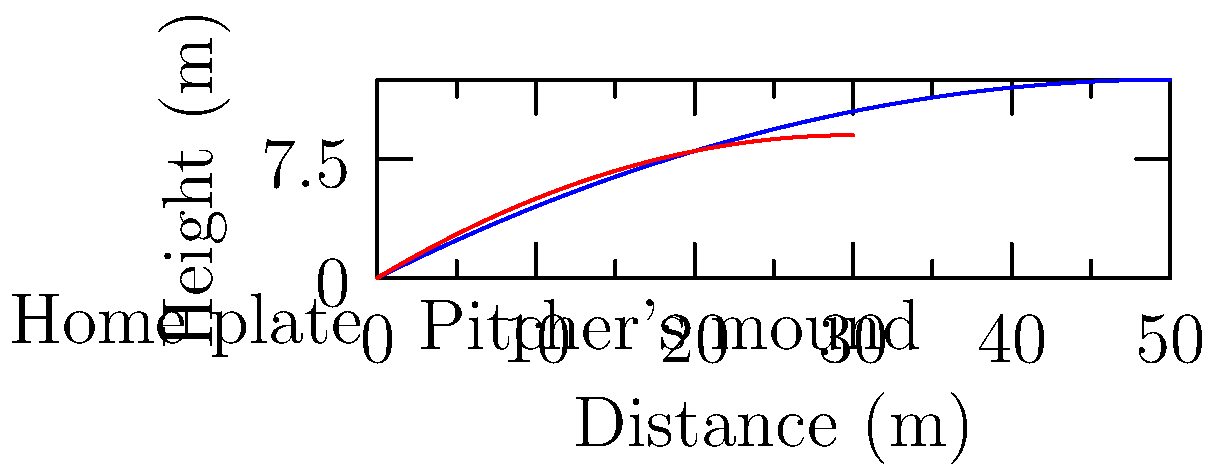Father Murphy was known for his unique pitching style during the annual church softball game. The blue curve represents a regular pitch, while the red curve shows Father Murphy's signature pitch. What factor likely contributed most to the difference in trajectories, and how might this have affected the batter's ability to hit the ball? To analyze the difference in trajectories:

1. Observe the curves:
   - Blue (regular pitch): longer, flatter trajectory
   - Red (Father Murphy's pitch): shorter, steeper trajectory

2. Consider factors affecting a pitch:
   - Initial velocity
   - Launch angle
   - Spin rate
   - Air resistance

3. Analyze the red curve:
   - Steeper initial ascent
   - Reaches maximum height quicker
   - Shorter overall distance

4. Conclude:
   - Father Murphy's pitch likely had a higher launch angle

5. Effects on the batter:
   - Less time to react due to steeper descent
   - Unexpected trajectory compared to standard pitches
   - Potential "rising" effect as the ball approaches

6. Biomechanical implication:
   - Father Murphy may have adjusted his arm angle or wrist position at release to achieve this trajectory

The higher launch angle would have made Father Murphy's pitches more challenging to hit, as batters would have less time to react and may misjudge the ball's path.
Answer: Higher launch angle, making pitches harder to hit due to steeper descent and less reaction time. 